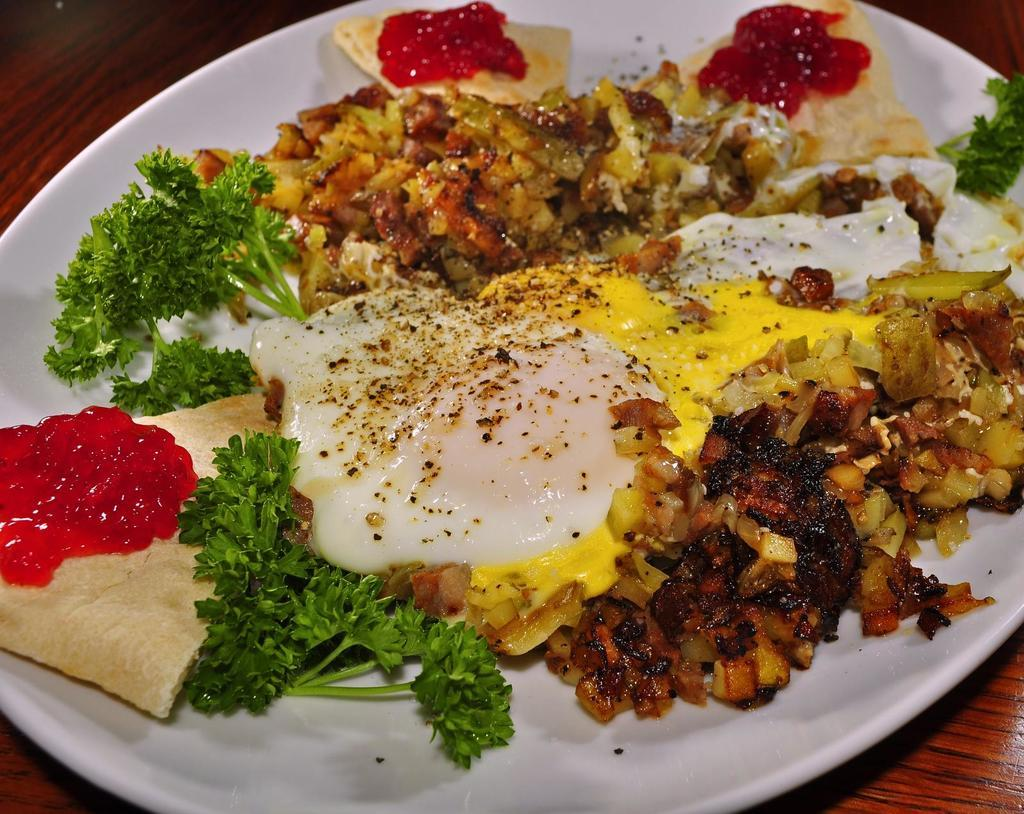What is the main subject of the image? The main subject of the image is food. How is the food presented in the image? The food is served on plates in the image. Where are the plates with food located? The plates with food are placed on a table. What is the girl thinking about while looking at the food in the image? There is no girl present in the image, so it is not possible to determine what she might be thinking. 